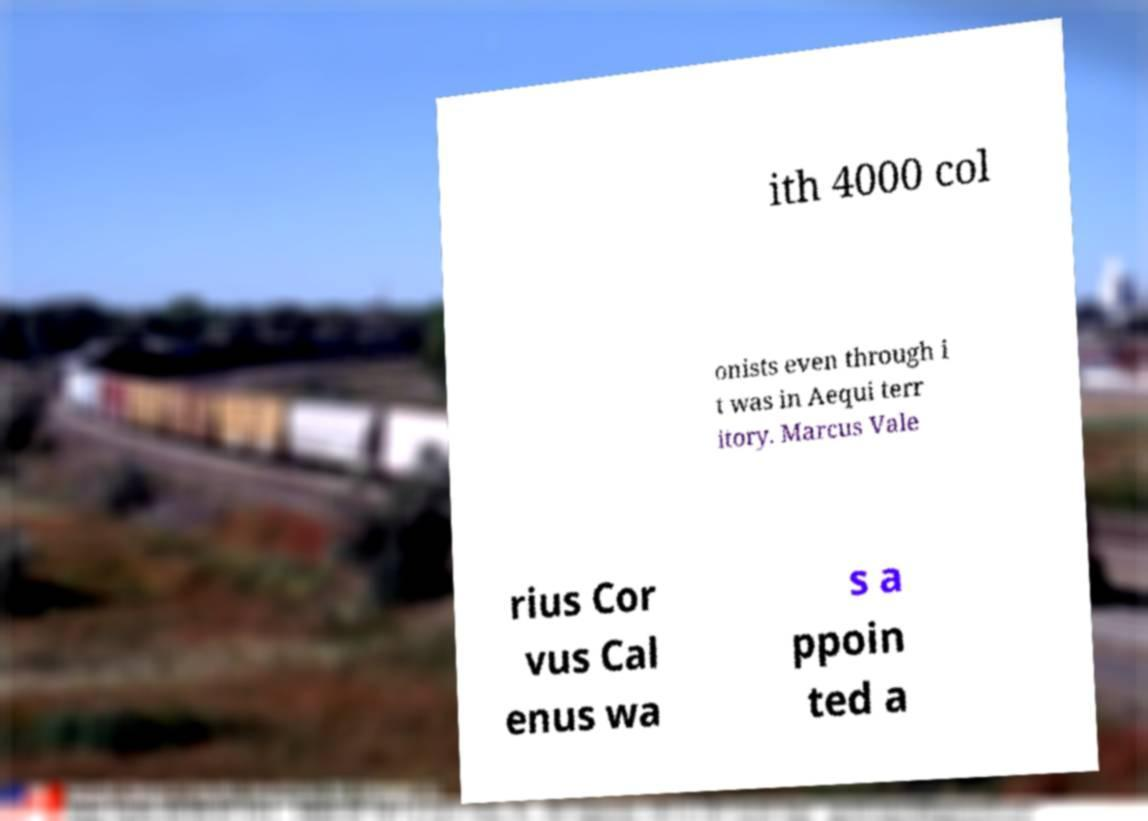What messages or text are displayed in this image? I need them in a readable, typed format. ith 4000 col onists even through i t was in Aequi terr itory. Marcus Vale rius Cor vus Cal enus wa s a ppoin ted a 